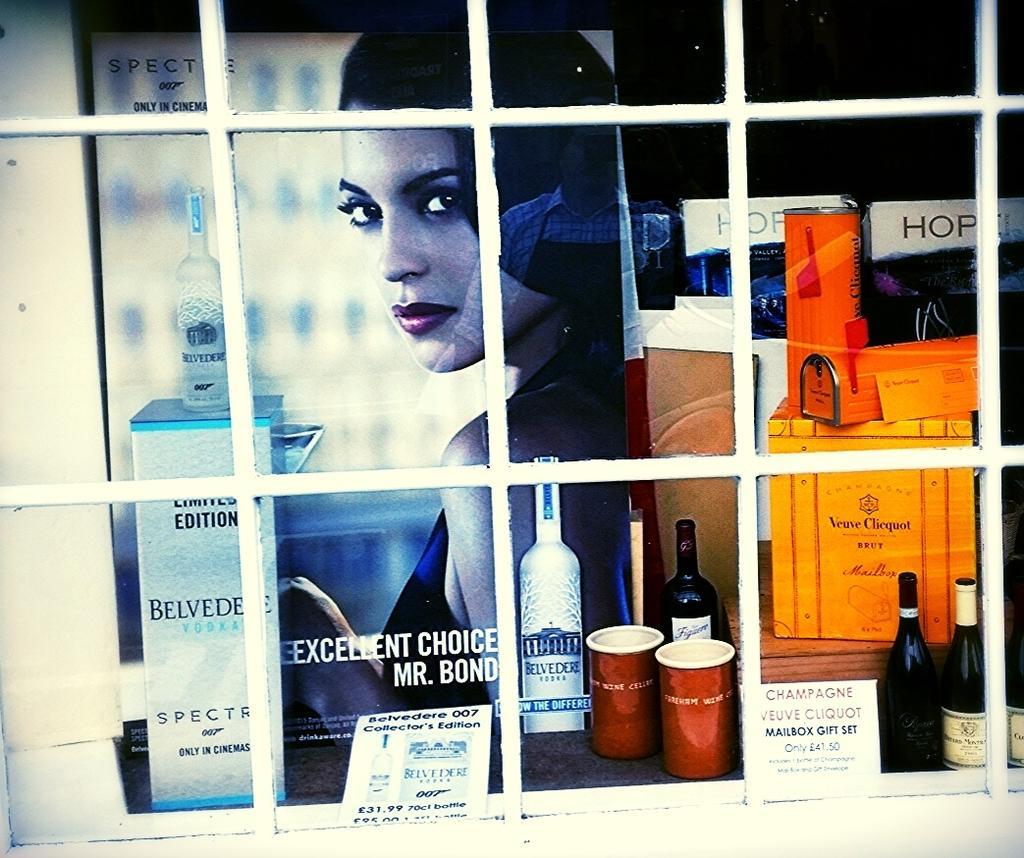Describe this image in one or two sentences. In this image we can see a window. Through the window we can see a poster and on the poster we can see an image of a person. We can see a group of objects behind the window. 